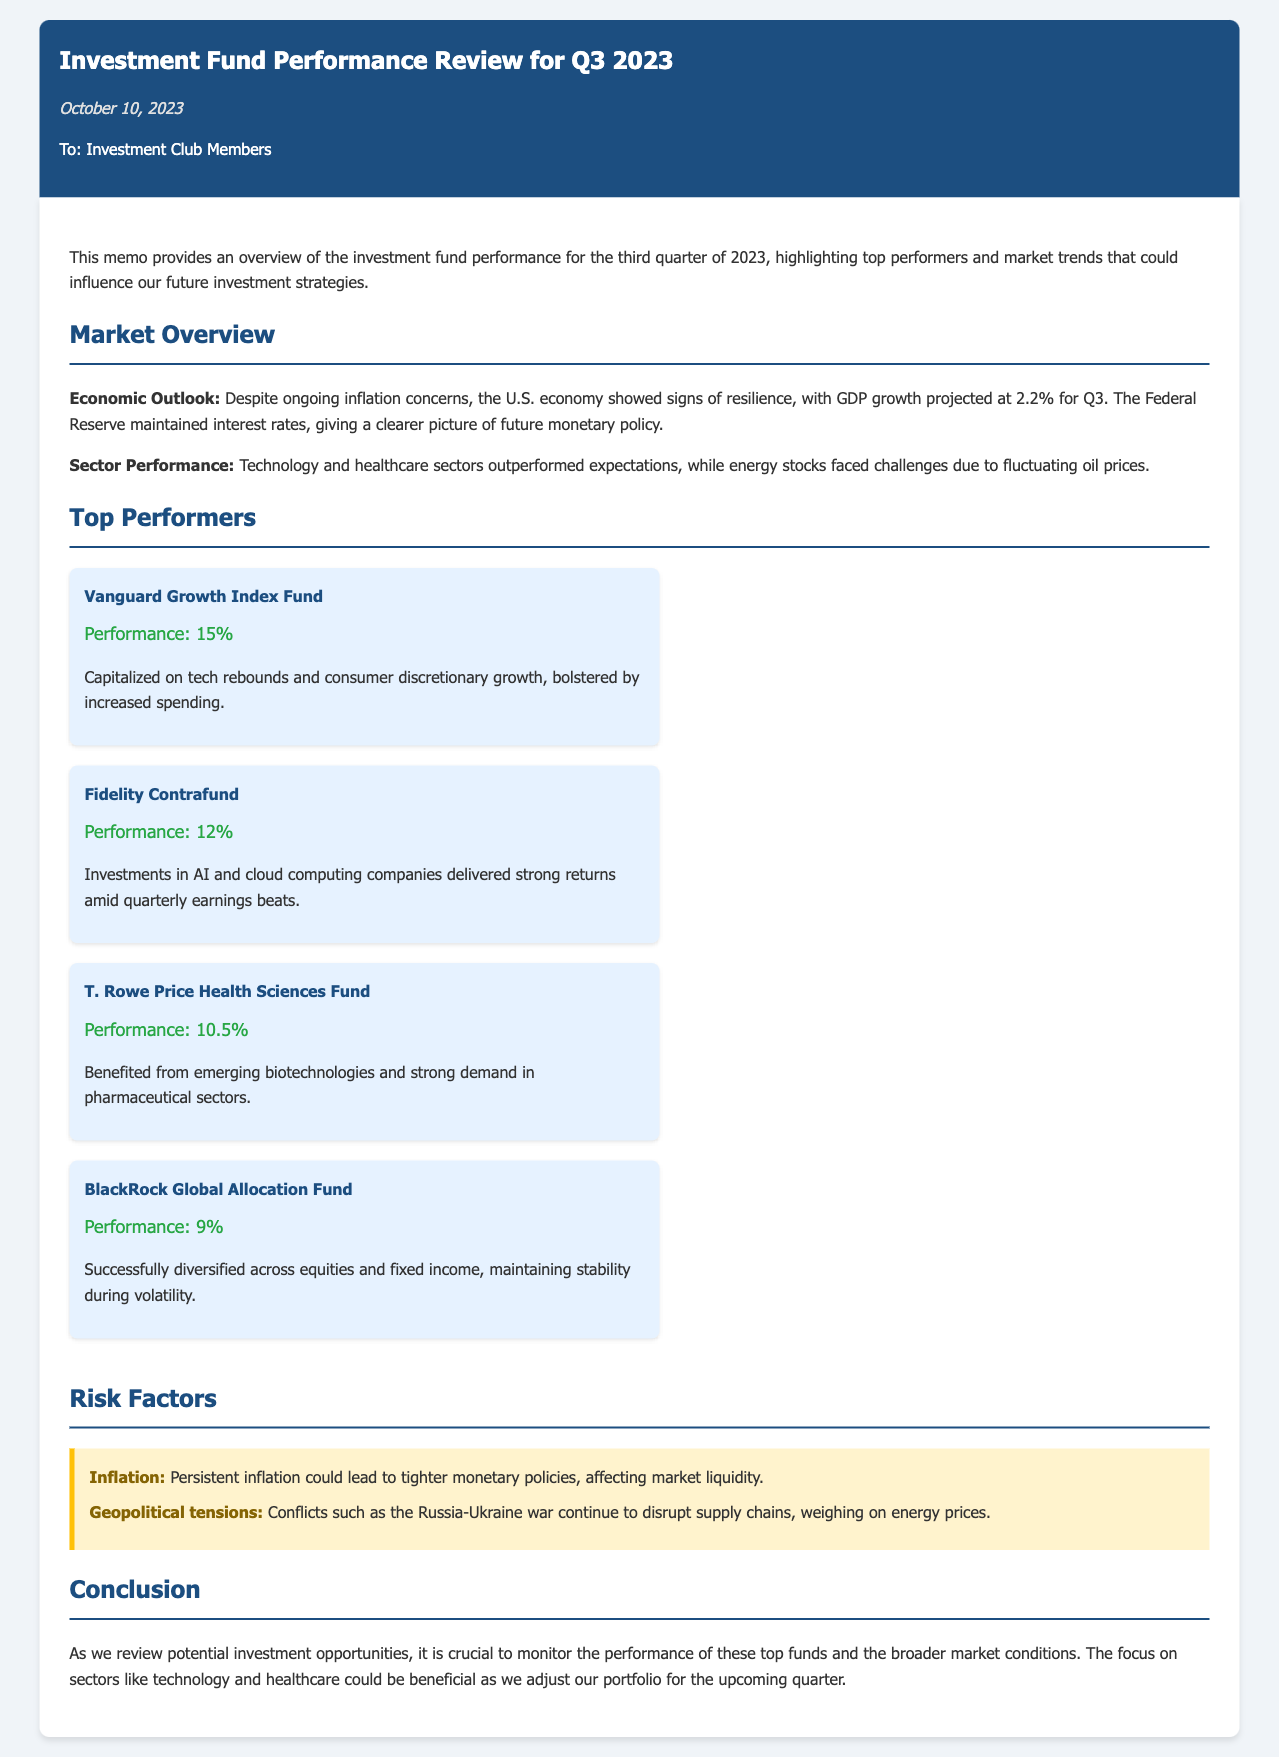What is the date of the memo? The memo is dated October 10, 2023, as mentioned under the date section.
Answer: October 10, 2023 What is the performance percentage of Vanguard Growth Index Fund? The performance of Vanguard Growth Index Fund is stated as 15% in the top performers section.
Answer: 15% Which sector outperformed expectations according to the memo? The memo indicates that the technology sector outperformed expectations in the sector performance section.
Answer: Technology Who are the top three performing funds? The top three performing funds listed are Vanguard Growth Index Fund, Fidelity Contrafund, and T. Rowe Price Health Sciences Fund, as detailed in the top performers section.
Answer: Vanguard Growth Index Fund, Fidelity Contrafund, T. Rowe Price Health Sciences Fund What was the projected GDP growth for Q3 2023? The projected GDP growth for Q3 2023 is mentioned as 2.2% in the economic outlook section.
Answer: 2.2% What risk factor relates to geopolitical tensions? The risk factor concerning geopolitical tensions is related to ongoing conflicts disrupting supply chains, as described in the risk factors section.
Answer: Conflicts disrupting supply chains What is the performance percentage of the BlackRock Global Allocation Fund? The performance percentage of the BlackRock Global Allocation Fund is stated as 9% in the top performers section.
Answer: 9% How many risk factors are mentioned in the memo? The memo mentions two risk factors in the risk factors section.
Answer: Two What conclusion does the memo emphasize regarding future investment? The memo emphasizes the importance of monitoring the performance of top funds and broader market conditions for future investments.
Answer: Monitor performance and market conditions 